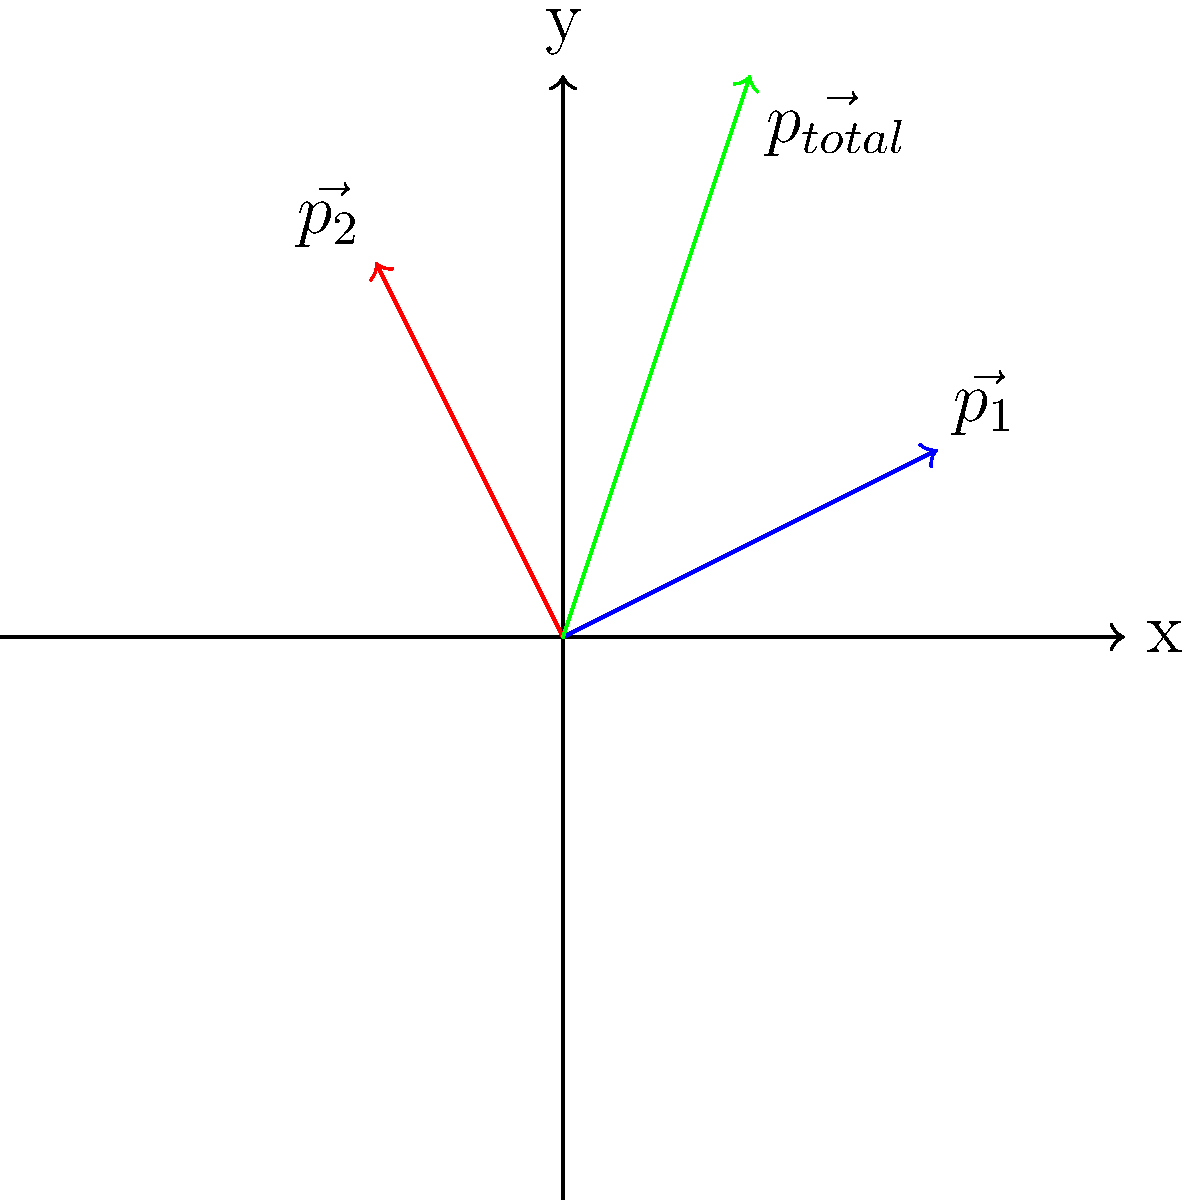In a football tackle, player A (mass 100 kg) running at 8 m/s collides with stationary player B (mass 90 kg). After the collision, both players move together at 4 m/s in player A's original direction. Using the vector diagram provided, calculate the change in momentum of player A during the collision. Let's approach this step-by-step:

1) First, we need to calculate the initial momentum of player A:
   $$\vec{p_1} = m_A \vec{v_A} = 100 \text{ kg} \cdot 8 \text{ m/s} = 800 \text{ kg}\cdot\text{m/s}$$

2) The final momentum of the combined players is:
   $$\vec{p_{total}} = (m_A + m_B) \vec{v_{final}} = (100 \text{ kg} + 90 \text{ kg}) \cdot 4 \text{ m/s} = 760 \text{ kg}\cdot\text{m/s}$$

3) The change in momentum is the difference between the final and initial momentum:
   $$\Delta \vec{p_A} = \vec{p_{total}} - \vec{p_1} = 760 \text{ kg}\cdot\text{m/s} - 800 \text{ kg}\cdot\text{m/s} = -40 \text{ kg}\cdot\text{m/s}$$

4) In the diagram, $\vec{p_1}$ represents player A's initial momentum, $\vec{p_2}$ represents player B's gained momentum, and $\vec{p_{total}}$ is the final combined momentum.

5) The change in momentum $\Delta \vec{p_A}$ is represented by the vector from the tip of $\vec{p_1}$ to the tip of $\vec{p_{total}}$, which is equal to $\vec{p_2}$ but in the opposite direction.
Answer: $-40 \text{ kg}\cdot\text{m/s}$ in the direction opposite to the initial motion 